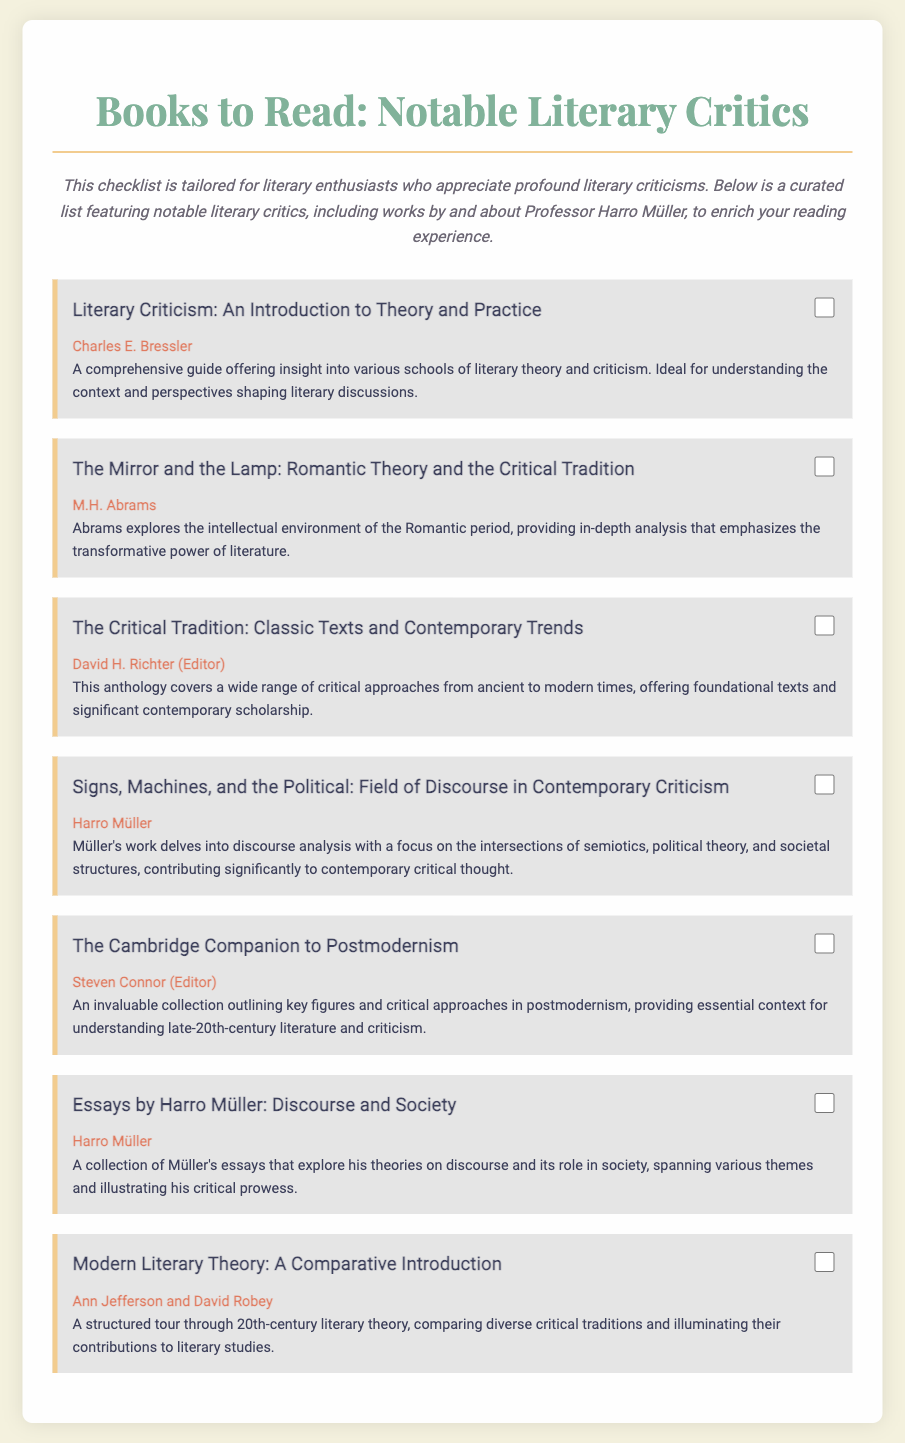What is the title of Harro Müller's work listed in the checklist? The title of Harro Müller's work included in the checklist is "Signs, Machines, and the Political: Field of Discourse in Contemporary Criticism."
Answer: Signs, Machines, and the Political: Field of Discourse in Contemporary Criticism Who is the author of "Literary Criticism: An Introduction to Theory and Practice"? The author of "Literary Criticism: An Introduction to Theory and Practice" is Charles E. Bressler.
Answer: Charles E. Bressler How many books are featured in the checklist? The checklist contains a total of seven books.
Answer: Seven Which editor contributed to "The Cambridge Companion to Postmodernism"? The editor of "The Cambridge Companion to Postmodernism" is Steven Connor.
Answer: Steven Connor What theme does Harro Müller's essay collection explore? Harro Müller's essay collection explores theories on discourse and its role in society.
Answer: Theories on discourse and its role in society Which book presents a comparative introduction to 20th-century literary theory? The book presenting a comparative introduction to 20th-century literary theory is "Modern Literary Theory: A Comparative Introduction."
Answer: Modern Literary Theory: A Comparative Introduction What kind of anthology is "The Critical Tradition"? "The Critical Tradition" is an anthology that covers a wide range of critical approaches.
Answer: Anthology of critical approaches 